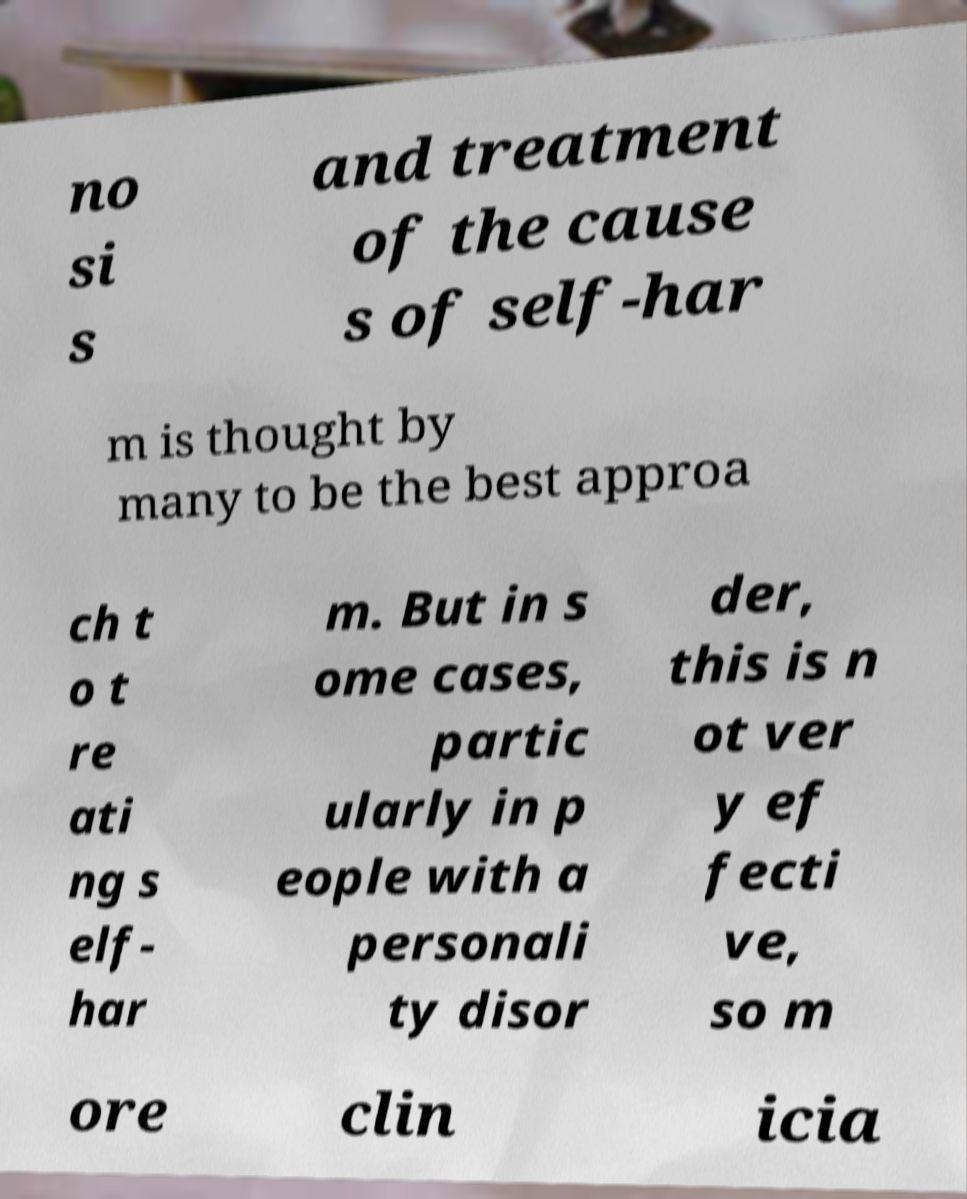I need the written content from this picture converted into text. Can you do that? no si s and treatment of the cause s of self-har m is thought by many to be the best approa ch t o t re ati ng s elf- har m. But in s ome cases, partic ularly in p eople with a personali ty disor der, this is n ot ver y ef fecti ve, so m ore clin icia 